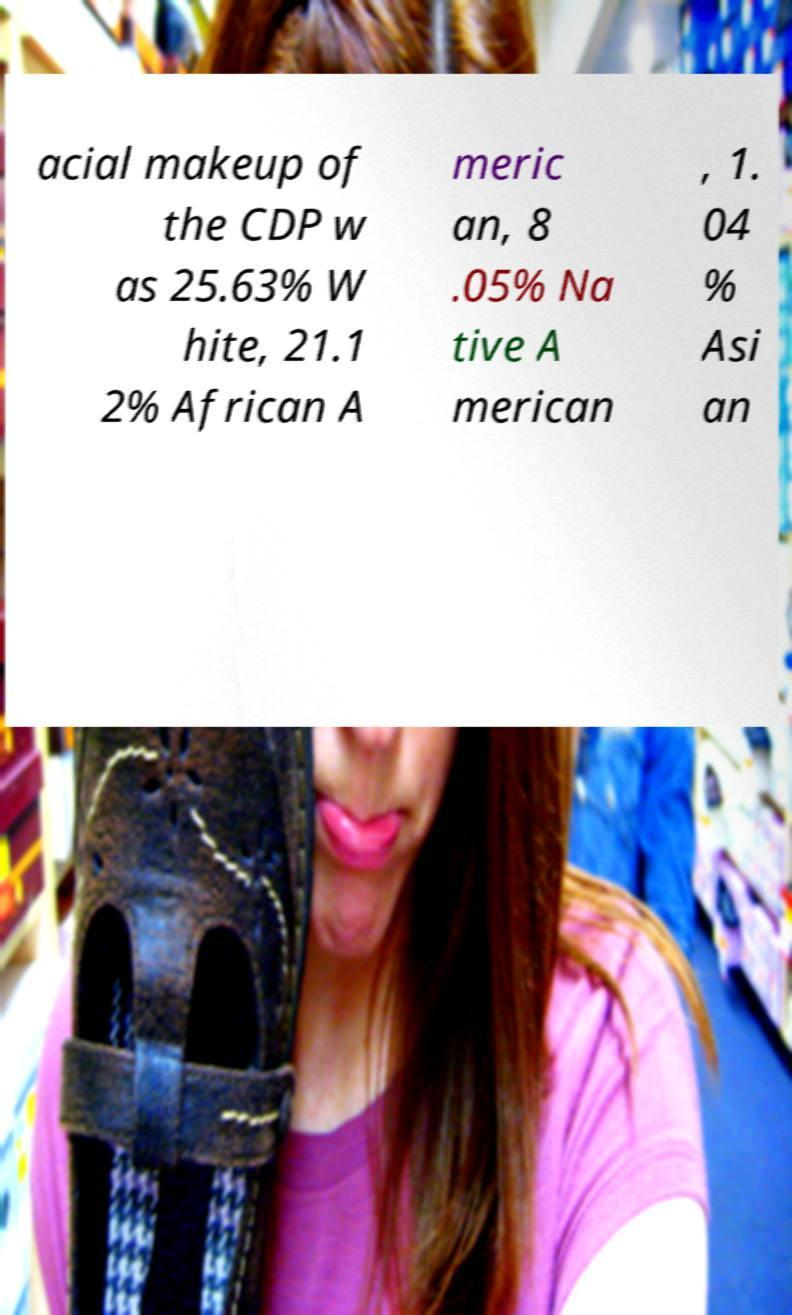Please read and relay the text visible in this image. What does it say? acial makeup of the CDP w as 25.63% W hite, 21.1 2% African A meric an, 8 .05% Na tive A merican , 1. 04 % Asi an 